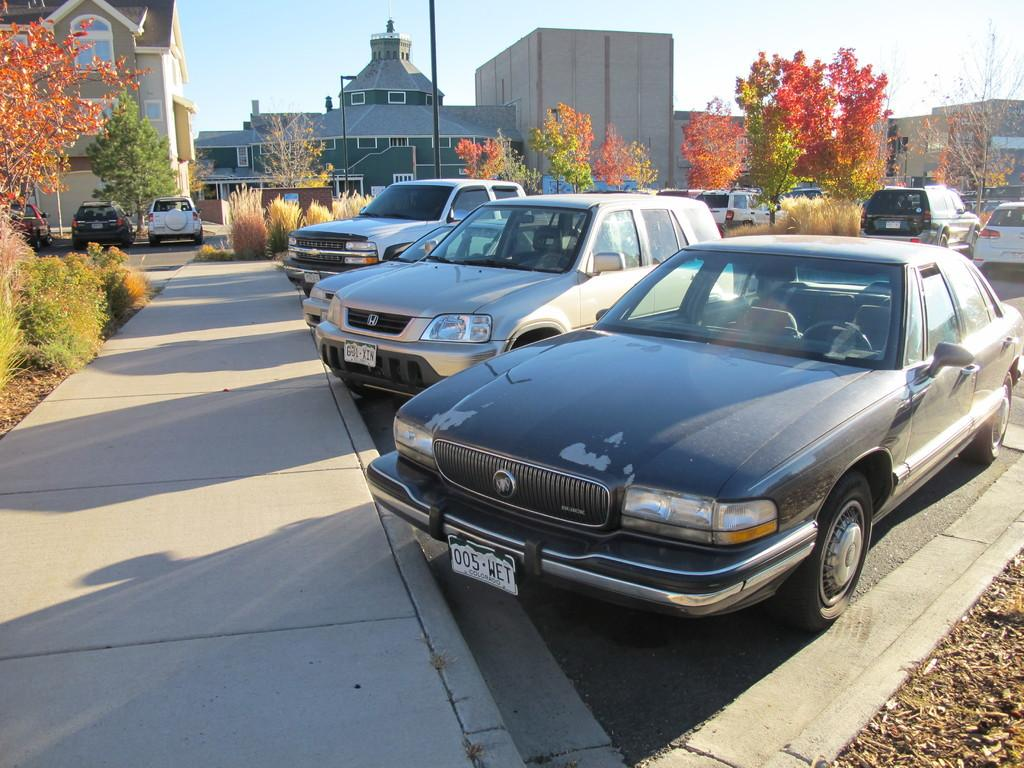What types of objects can be seen in the image? There are vehicles, trees, and plants in the image. What can be seen in the background of the image? There are buildings with windows and a black pole in the background. What brand of toothpaste is being advertised on the vehicles in the image? There is no toothpaste or advertisement present on the vehicles in the image. How many wrists are visible in the image? There are no visible wrists in the image. 